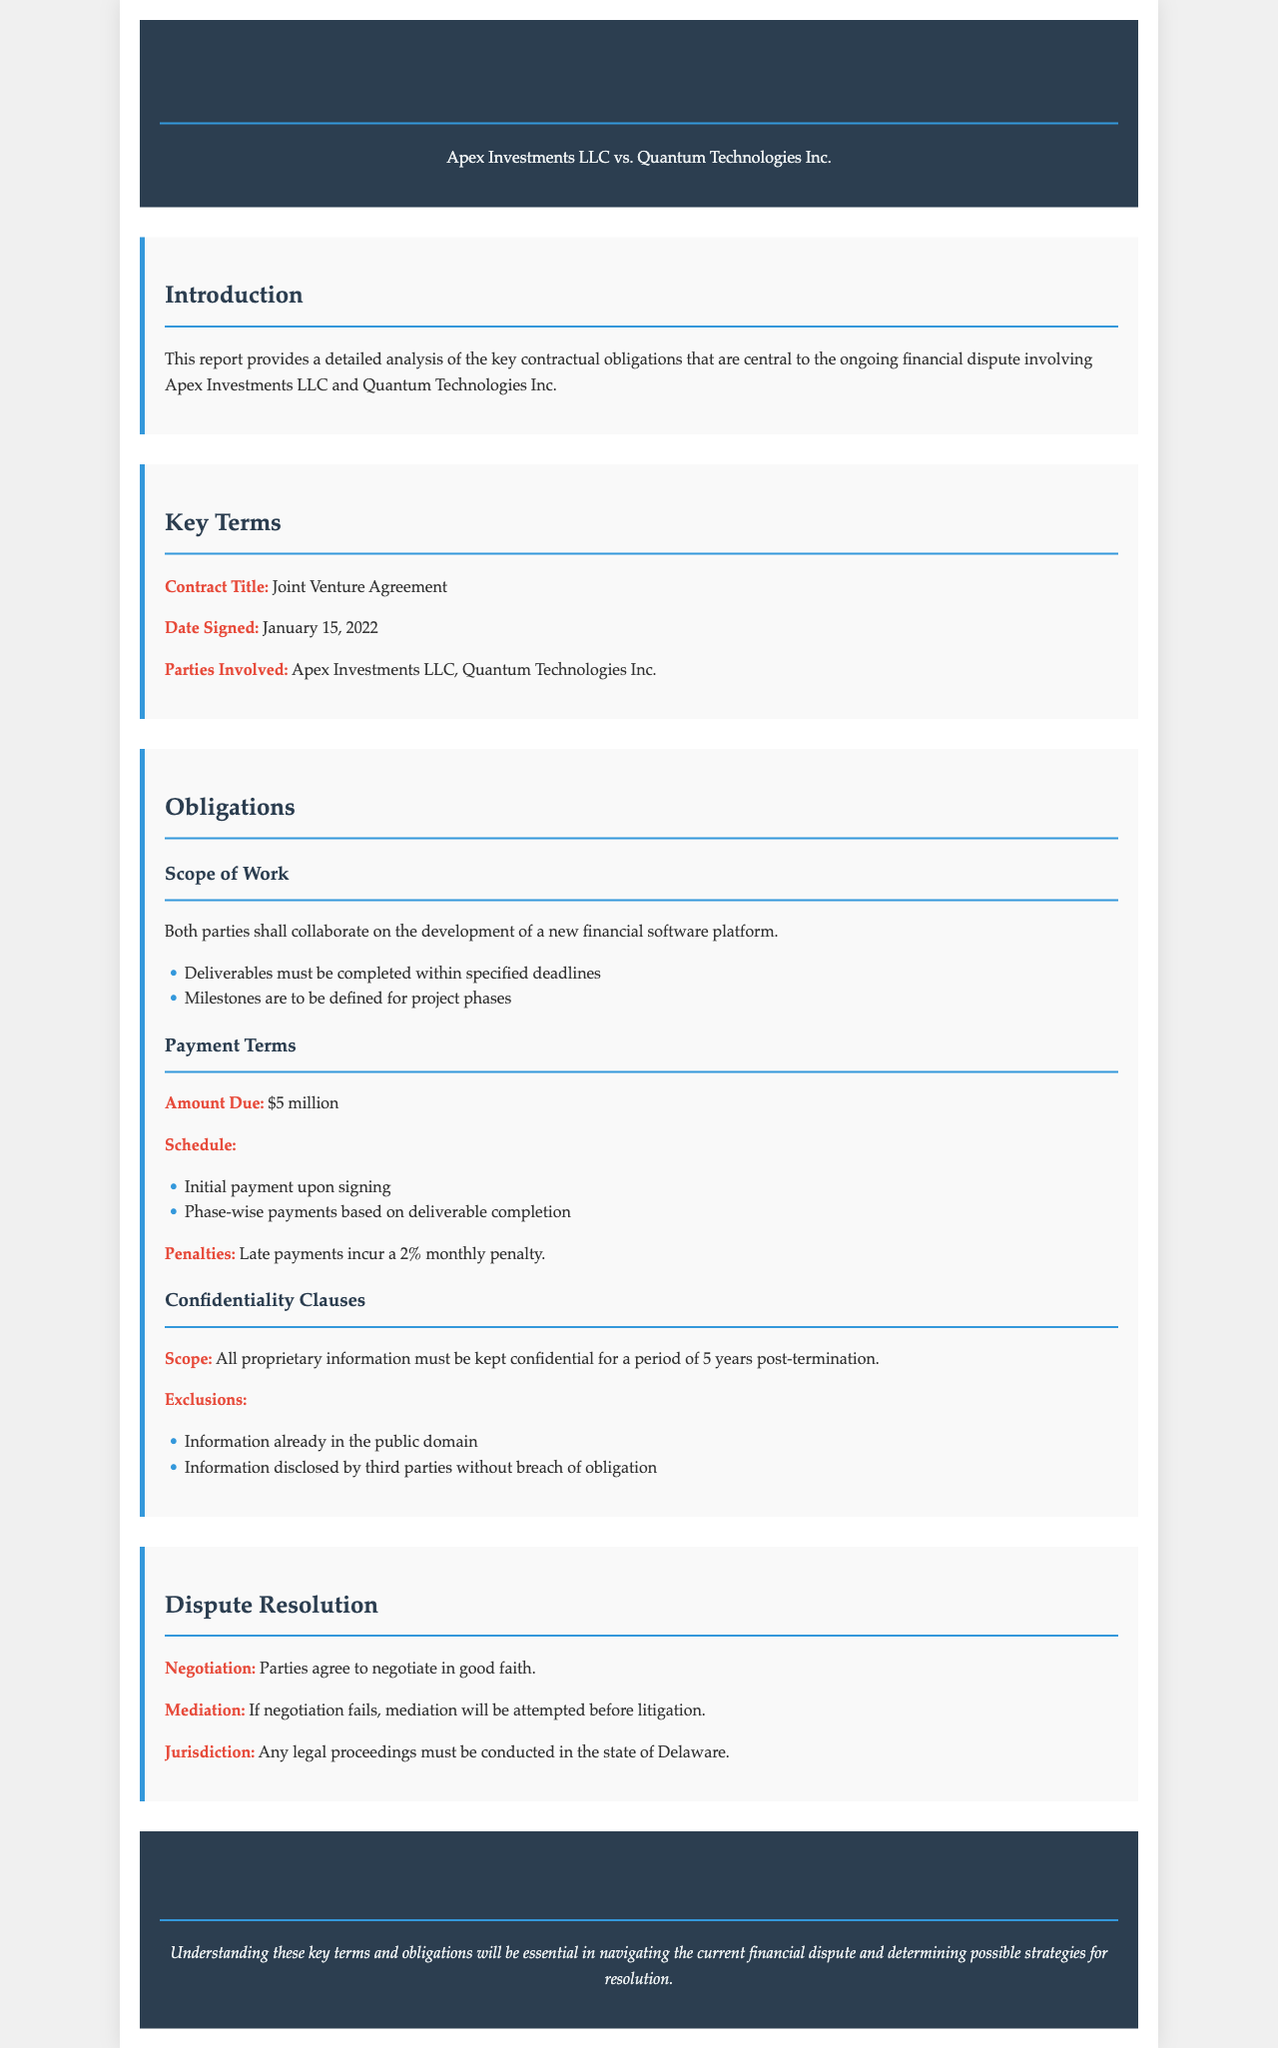What is the title of the contract? The title of the contract, as mentioned in the document, is Joint Venture Agreement.
Answer: Joint Venture Agreement When was the contract signed? The date when the contract was signed is specified in the document as January 15, 2022.
Answer: January 15, 2022 What is the amount due under the payment terms? The amount due specified in the payment terms is $5 million.
Answer: $5 million What is the penalty for late payments? The document states that the penalty for late payments is a 2% monthly penalty.
Answer: 2% monthly penalty For how long must proprietary information be kept confidential? The document specifies that proprietary information must be kept confidential for a period of 5 years post-termination.
Answer: 5 years What is the first step in the dispute resolution process? The first step in the dispute resolution process, as stated in the document, is to negotiate in good faith.
Answer: Negotiate in good faith Where must legal proceedings be conducted? The jurisdiction for any legal proceedings, according to the document, is the state of Delaware.
Answer: Delaware What must be defined for project phases according to the obligations? The document notes that milestones must be defined for project phases related to the obligations.
Answer: Milestones 